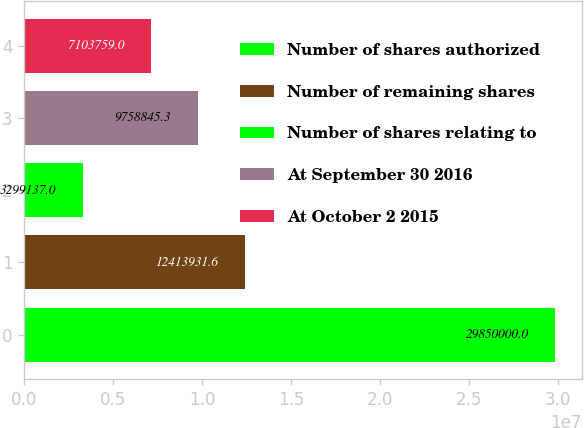<chart> <loc_0><loc_0><loc_500><loc_500><bar_chart><fcel>Number of shares authorized<fcel>Number of remaining shares<fcel>Number of shares relating to<fcel>At September 30 2016<fcel>At October 2 2015<nl><fcel>2.985e+07<fcel>1.24139e+07<fcel>3.29914e+06<fcel>9.75885e+06<fcel>7.10376e+06<nl></chart> 